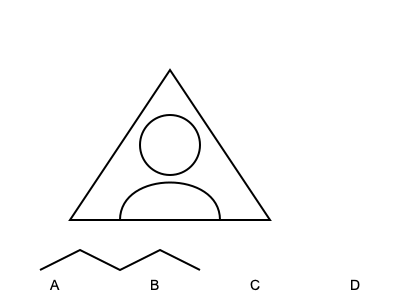Which of the outlined drawings (A, B, C, or D) represents a common Native American projectile point, often found in Kentucky archaeological sites? To identify the Native American projectile point commonly found in Kentucky archaeological sites, let's analyze each drawing:

1. Drawing A: This triangular shape with straight sides is characteristic of a projectile point, specifically an arrowhead. Native Americans in Kentucky often crafted such tools from flint or chert.

2. Drawing B: This curved line resembles a pottery shard or fragment, which is also common in archaeological sites but not a projectile point.

3. Drawing C: The circular shape could represent a bead or decorative item, but it's not a projectile point.

4. Drawing D: This wavy line might depict a river or decorative pattern on pottery, but it's not a projectile point.

Among these options, only Drawing A accurately represents a projectile point commonly found in Kentucky archaeological sites. The triangular shape is designed for piercing and attaching to arrow shafts, making it an effective hunting and warfare tool used by Native Americans in the region.
Answer: A 